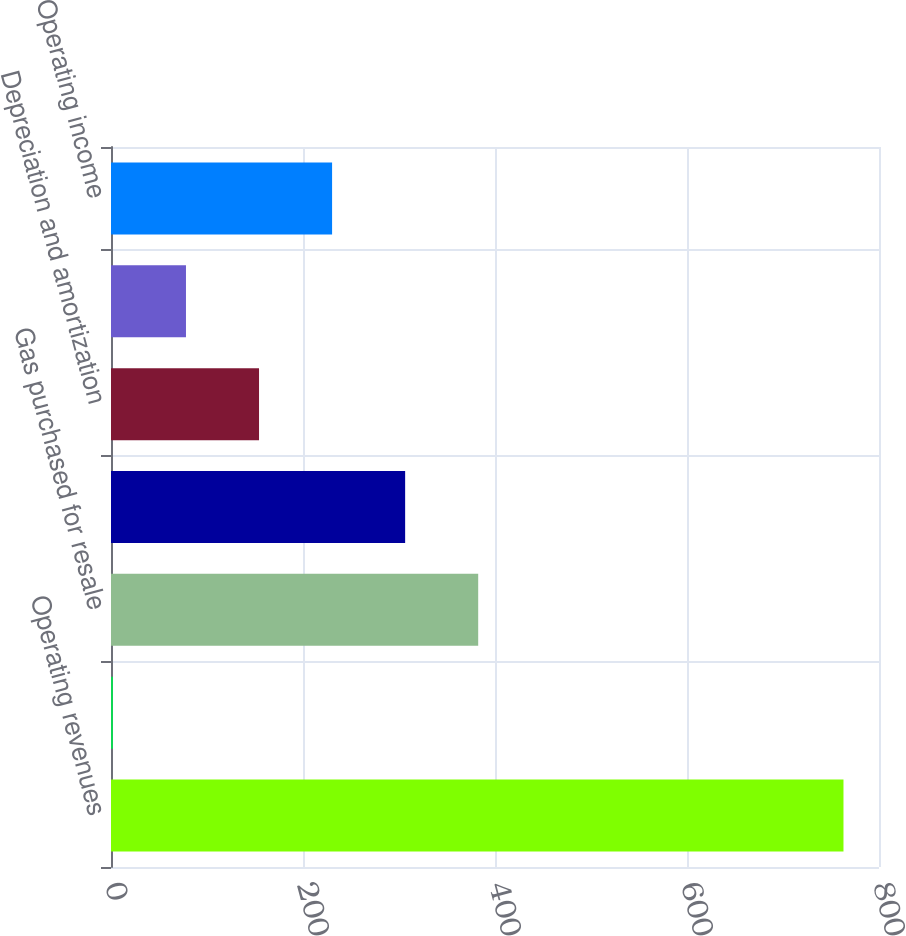<chart> <loc_0><loc_0><loc_500><loc_500><bar_chart><fcel>Operating revenues<fcel>Purchased power<fcel>Gas purchased for resale<fcel>Other operations and<fcel>Depreciation and amortization<fcel>Taxes other than income taxes<fcel>Operating income<nl><fcel>763<fcel>2<fcel>382.5<fcel>306.4<fcel>154.2<fcel>78.1<fcel>230.3<nl></chart> 